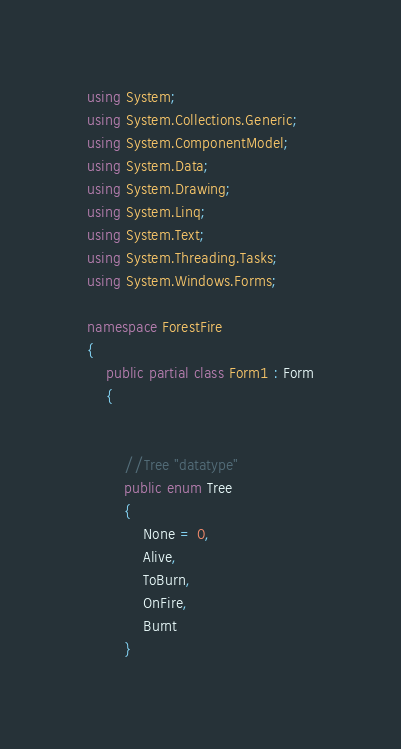<code> <loc_0><loc_0><loc_500><loc_500><_C#_>using System;
using System.Collections.Generic;
using System.ComponentModel;
using System.Data;
using System.Drawing;
using System.Linq;
using System.Text;
using System.Threading.Tasks;
using System.Windows.Forms;

namespace ForestFire
{
    public partial class Form1 : Form
    {


        //Tree "datatype"
        public enum Tree
        {
            None = 0,
            Alive,
            ToBurn,
            OnFire,
            Burnt 
        }
</code> 